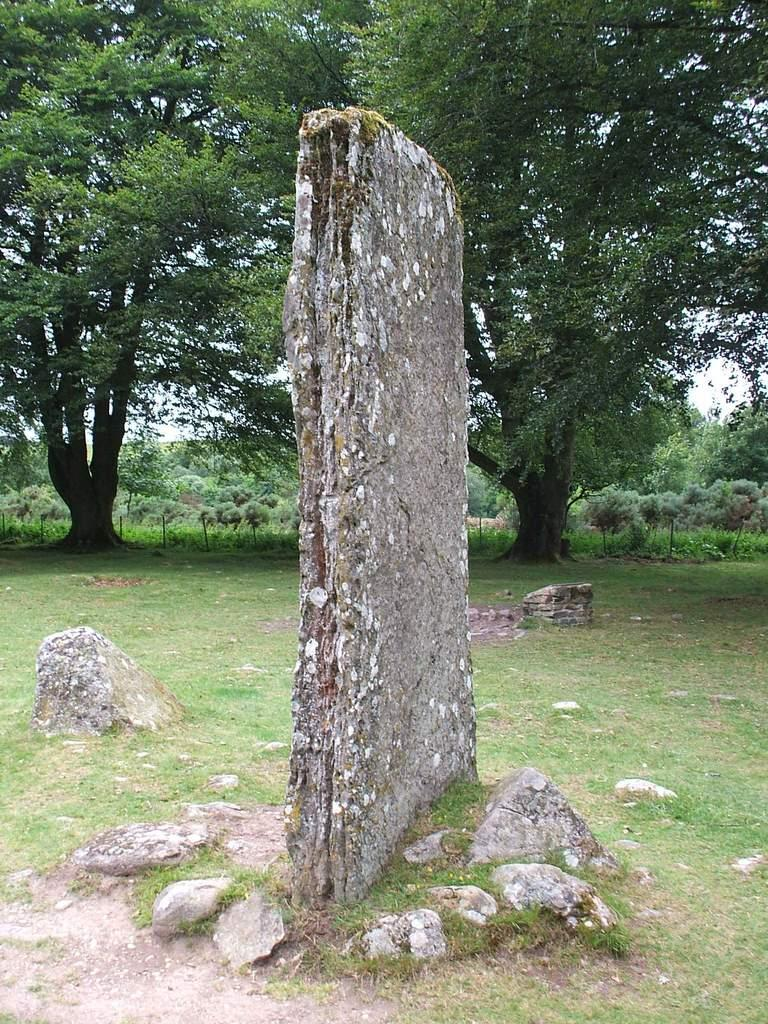What type of object can be seen in the image? There is a stone in the image. Are there any other similar objects in the image? Yes, there are rocks in the image. What type of vegetation is present in the image? There are trees with branches and leaves in the image. What is the ground covered with in the image? There is grass in the image. Can you see an ornament hanging from the tree in the image? There is no ornament hanging from the tree in the image. Are there any keys visible on the ground in the image? There are no keys visible on the ground in the image. 